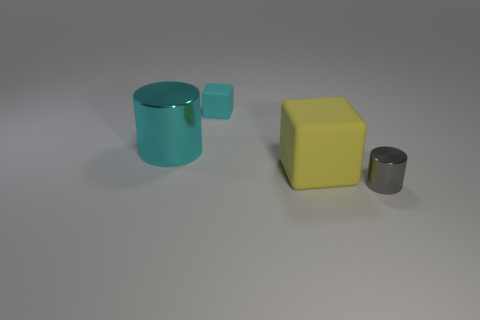Add 1 big green rubber blocks. How many objects exist? 5 Subtract 1 gray cylinders. How many objects are left? 3 Subtract all big blue rubber objects. Subtract all gray objects. How many objects are left? 3 Add 3 metal objects. How many metal objects are left? 5 Add 1 big cyan cylinders. How many big cyan cylinders exist? 2 